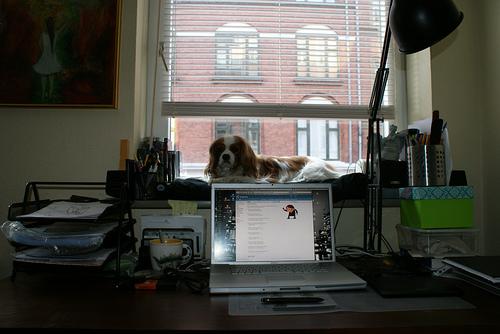Is it an indoor scene?
Short answer required. Yes. What animal is sitting near the window?
Be succinct. Dog. Is that a desktop computer?
Quick response, please. No. 